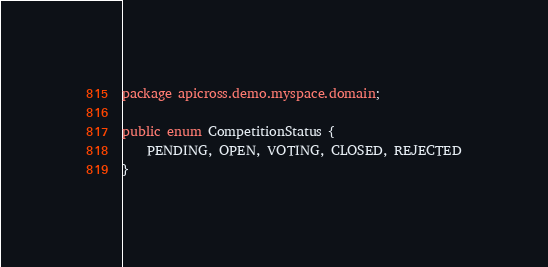<code> <loc_0><loc_0><loc_500><loc_500><_Java_>package apicross.demo.myspace.domain;

public enum CompetitionStatus {
    PENDING, OPEN, VOTING, CLOSED, REJECTED
}
</code> 